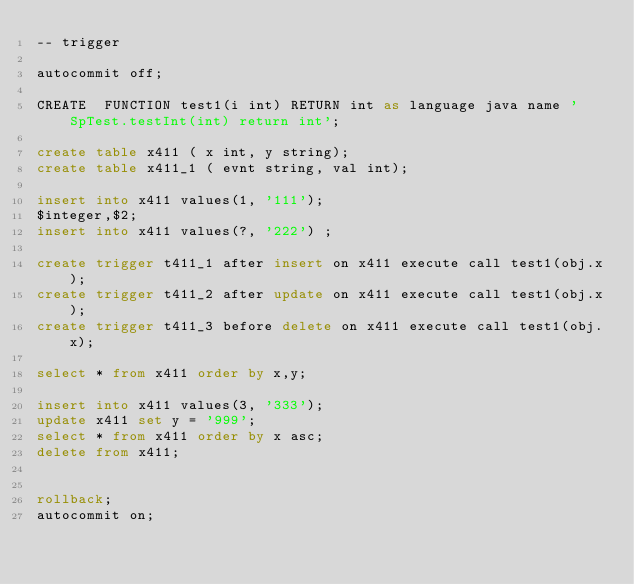Convert code to text. <code><loc_0><loc_0><loc_500><loc_500><_SQL_>-- trigger

autocommit off;

CREATE  FUNCTION test1(i int) RETURN int as language java name 'SpTest.testInt(int) return int';

create table x411 ( x int, y string);
create table x411_1 ( evnt string, val int);

insert into x411 values(1, '111');
$integer,$2;
insert into x411 values(?, '222') ;

create trigger t411_1 after insert on x411 execute call test1(obj.x);
create trigger t411_2 after update on x411 execute call test1(obj.x);
create trigger t411_3 before delete on x411 execute call test1(obj.x);

select * from x411 order by x,y;

insert into x411 values(3, '333');
update x411 set y = '999';
select * from x411 order by x asc;
delete from x411;


rollback;
autocommit on;

</code> 